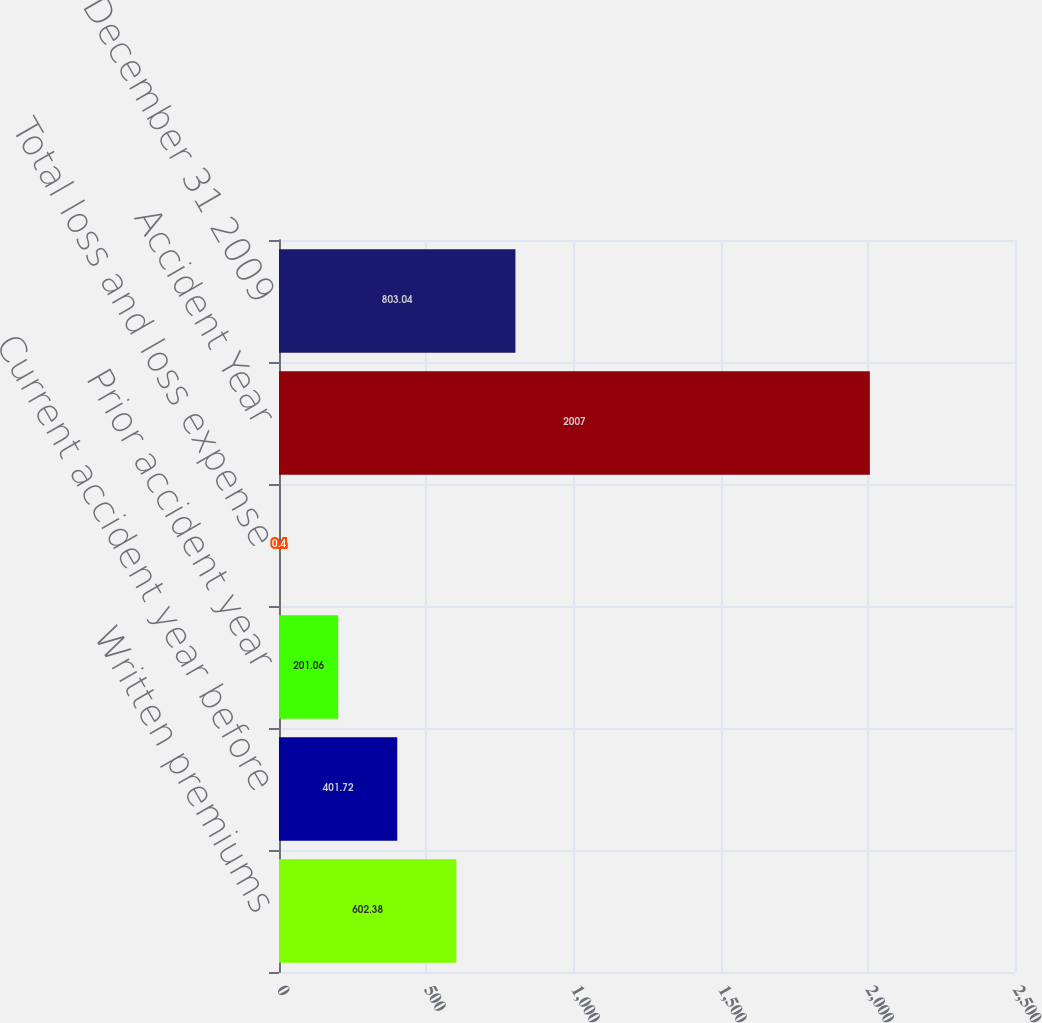Convert chart. <chart><loc_0><loc_0><loc_500><loc_500><bar_chart><fcel>Written premiums<fcel>Current accident year before<fcel>Prior accident year<fcel>Total loss and loss expense<fcel>Accident Year<fcel>as of December 31 2009<nl><fcel>602.38<fcel>401.72<fcel>201.06<fcel>0.4<fcel>2007<fcel>803.04<nl></chart> 